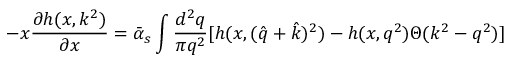Convert formula to latex. <formula><loc_0><loc_0><loc_500><loc_500>- x { \frac { \partial h ( x , k ^ { 2 } ) } { \partial x } } = \bar { \alpha } _ { s } \int { \frac { d ^ { 2 } q } { \pi q ^ { 2 } } } [ h ( x , ( \hat { q } + \hat { k } ) ^ { 2 } ) - h ( x , q ^ { 2 } ) \Theta ( k ^ { 2 } - q ^ { 2 } ) ]</formula> 